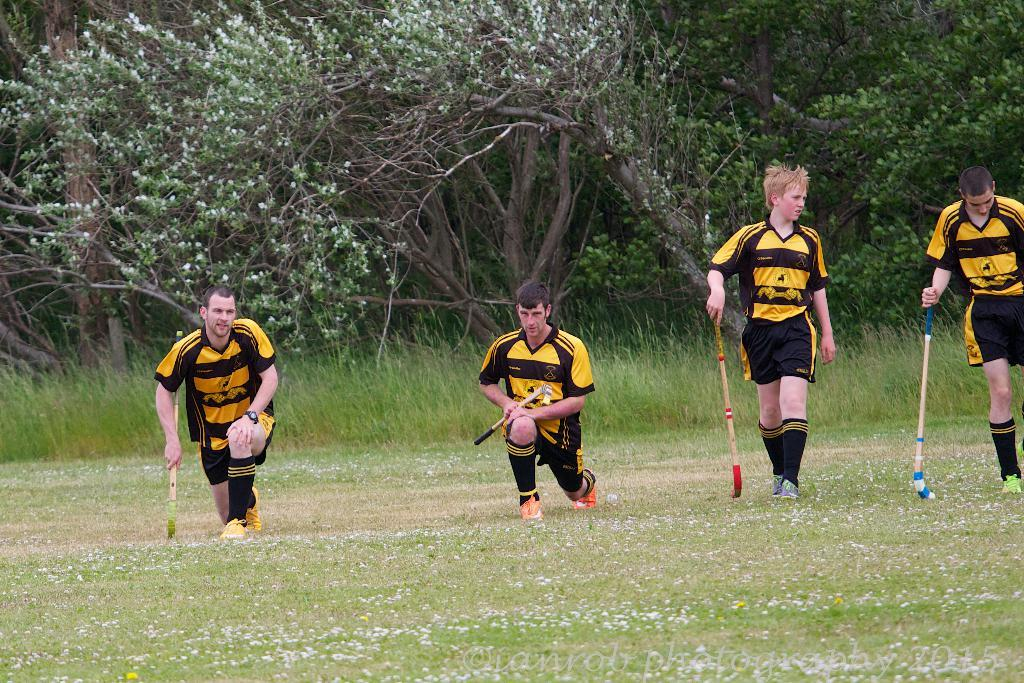How many people are in the image? There are four people in the image. What are the people holding in the image? The people are holding hockey sticks. What type of surface is the ground made of in the image? There is grass on the ground in the image. What can be seen in the background of the image? There are plants and trees in the background of the image. What type of polish is being applied to the stage in the image? There is no stage or polish present in the image; it features four people holding hockey sticks on a grassy surface with plants and trees in the background. 